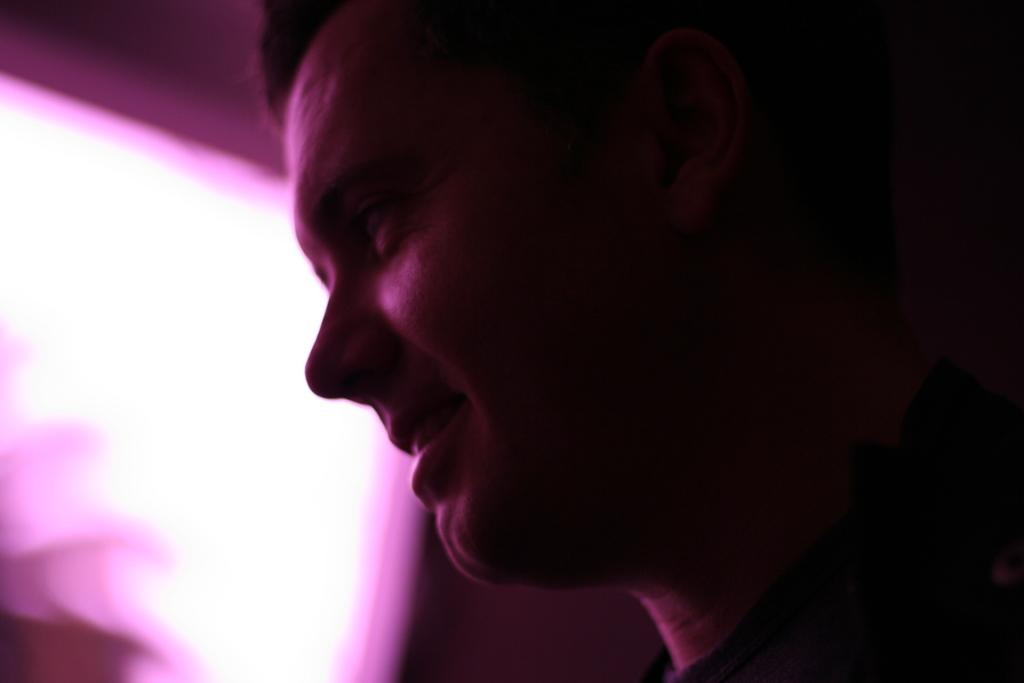What is the main subject of the image? There is a person's face in the image. Can you describe the background of the image? The background of the image is blurry. How many bikes are parked behind the person in the image? There is no information about bikes in the image, as it only features a person's face and a blurry background. 